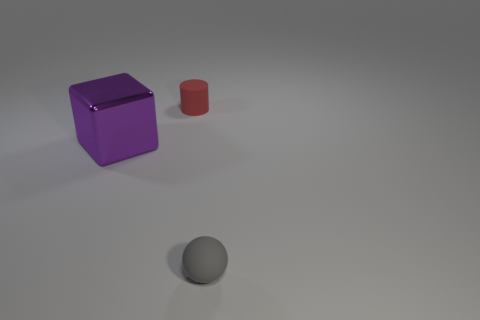Add 3 red rubber cylinders. How many objects exist? 6 Subtract all cubes. How many objects are left? 2 Subtract 0 purple cylinders. How many objects are left? 3 Subtract all large brown cylinders. Subtract all tiny red rubber objects. How many objects are left? 2 Add 1 gray objects. How many gray objects are left? 2 Add 1 red objects. How many red objects exist? 2 